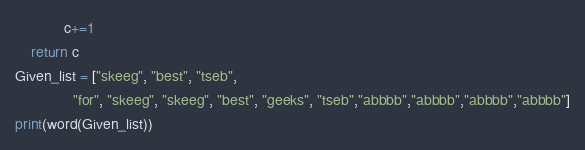<code> <loc_0><loc_0><loc_500><loc_500><_Python_>            c+=1
    return c
Given_list = ["skeeg", "best", "tseb",
              "for", "skeeg", "skeeg", "best", "geeks", "tseb","abbbb","abbbb","abbbb","abbbb"]
print(word(Given_list))
</code> 